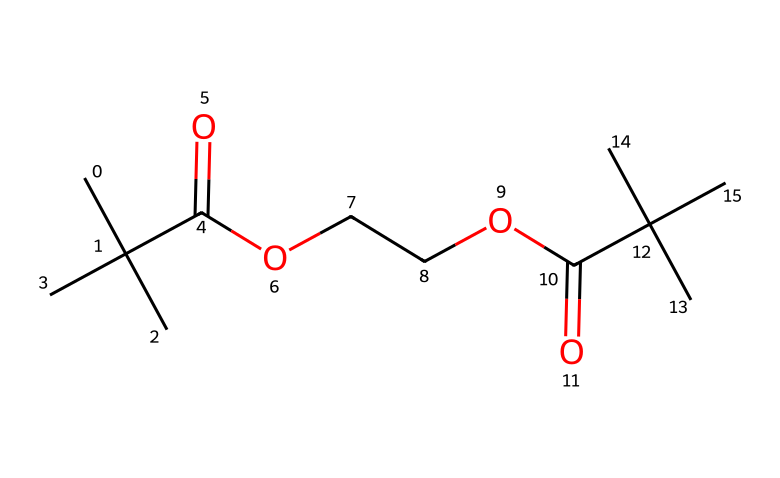What type of functional groups are present in this polymer? The structure contains carboxylic acid (–COOH) and ester (–COOC) functional groups. The presence of these groups can be identified from the specific arrangements of carbon, oxygen, and hydrogen atoms.
Answer: carboxylic acid and ester How many carbon atoms are in this polymer? By analyzing the SMILES notation, the structure can be broken down to count the carbon (C) atoms. There are a total of 12 carbon atoms in the given chemical structure.
Answer: 12 What is the degree of branching in this chemical structure? The presence of tertiary carbon atoms indicates that there is branching in the structure. In this case, multiple carbon branches are visible, suggesting a high degree of branching.
Answer: high Which elements are present other than carbon in this chemical? The elements present besides carbon can be determined by examining the SMILES, which includes oxygen (O) and hydrogen (H). Thus, the other elements in the chemical are oxygen and hydrogen.
Answer: oxygen and hydrogen What is the main implication of using this polymer for coffee cups? Since the polymer is biodegradable due to the presence of ester and carboxylic acid functional groups, it implies that this material can decompose and reduce environmental impact compared to traditional plastics.
Answer: biodegradable How many functional groups are found in the chemical structure? The structure contains two different functional groups: one carboxylic acid group and two ester groups, which totals three functional groups in the polymer.
Answer: three 